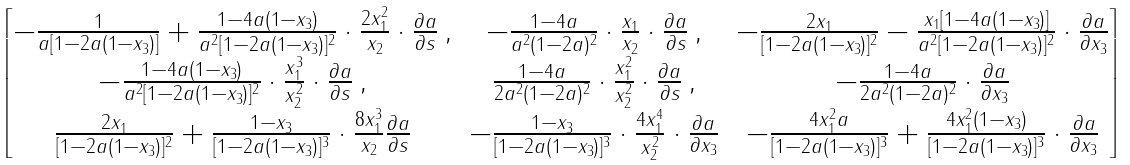Convert formula to latex. <formula><loc_0><loc_0><loc_500><loc_500>\begin{bmatrix} - \frac { 1 } { a [ 1 - 2 a ( 1 - x _ { 3 } ) ] } + \frac { 1 - 4 a ( 1 - x _ { 3 } ) } { a ^ { 2 } [ 1 - 2 a ( 1 - x _ { 3 } ) ] ^ { 2 } } \cdot \frac { 2 x _ { 1 } ^ { 2 } } { x _ { 2 } } \cdot \frac { \partial a } { \partial s } \, , & - \frac { 1 - 4 a } { a ^ { 2 } ( 1 - 2 a ) ^ { 2 } } \cdot \frac { x _ { 1 } } { x _ { 2 } } \cdot \frac { \partial a } { \partial s } \, , & - \frac { 2 x _ { 1 } } { [ 1 - 2 a ( 1 - x _ { 3 } ) ] ^ { 2 } } - \frac { x _ { 1 } [ 1 - 4 a ( 1 - x _ { 3 } ) ] } { a ^ { 2 } [ 1 - 2 a ( 1 - x _ { 3 } ) ] ^ { 2 } } \cdot \frac { \partial a } { \partial x _ { 3 } } \\ - \frac { 1 - 4 a ( 1 - x _ { 3 } ) } { a ^ { 2 } [ 1 - 2 a ( 1 - x _ { 3 } ) ] ^ { 2 } } \cdot \frac { x _ { 1 } ^ { 3 } } { x _ { 2 } ^ { 2 } } \cdot \frac { \partial a } { \partial s } \, , & \frac { 1 - 4 a } { 2 a ^ { 2 } ( 1 - 2 a ) ^ { 2 } } \cdot \frac { x _ { 1 } ^ { 2 } } { x _ { 2 } ^ { 2 } } \cdot \frac { \partial a } { \partial s } \, , & - \frac { 1 - 4 a } { 2 a ^ { 2 } ( 1 - 2 a ) ^ { 2 } } \cdot \frac { \partial a } { \partial x _ { 3 } } \\ \frac { 2 x _ { 1 } } { [ 1 - 2 a ( 1 - x _ { 3 } ) ] ^ { 2 } } + \frac { 1 - x _ { 3 } } { [ 1 - 2 a ( 1 - x _ { 3 } ) ] ^ { 3 } } \cdot \frac { 8 x _ { 1 } ^ { 3 } } { x _ { 2 } } \frac { \partial a } { \partial s } & - \frac { 1 - x _ { 3 } } { [ 1 - 2 a ( 1 - x _ { 3 } ) ] ^ { 3 } } \cdot \frac { 4 x _ { 1 } ^ { 4 } } { x _ { 2 } ^ { 2 } } \cdot \frac { \partial a } { \partial x _ { 3 } } & - \frac { 4 x _ { 1 } ^ { 2 } a } { [ 1 - 2 a ( 1 - x _ { 3 } ) ] ^ { 3 } } + \frac { 4 x _ { 1 } ^ { 2 } ( 1 - x _ { 3 } ) } { [ 1 - 2 a ( 1 - x _ { 3 } ) ] ^ { 3 } } \cdot \frac { \partial a } { \partial x _ { 3 } } \end{bmatrix}</formula> 